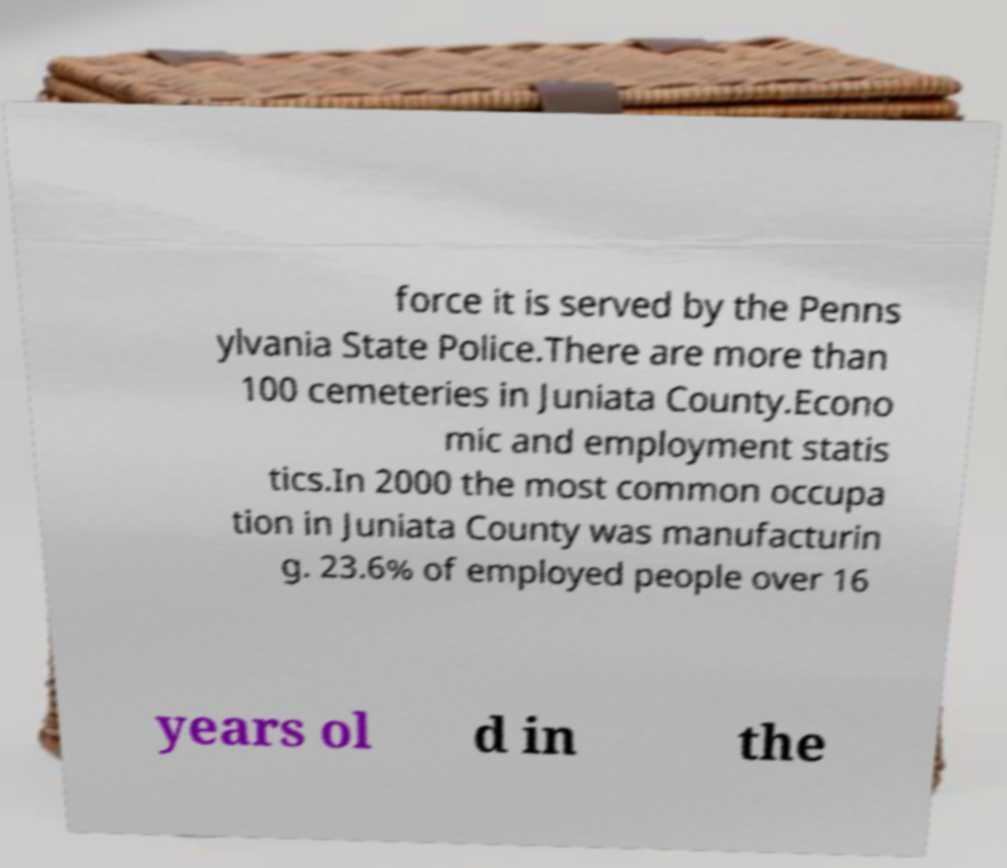Could you assist in decoding the text presented in this image and type it out clearly? force it is served by the Penns ylvania State Police.There are more than 100 cemeteries in Juniata County.Econo mic and employment statis tics.In 2000 the most common occupa tion in Juniata County was manufacturin g. 23.6% of employed people over 16 years ol d in the 